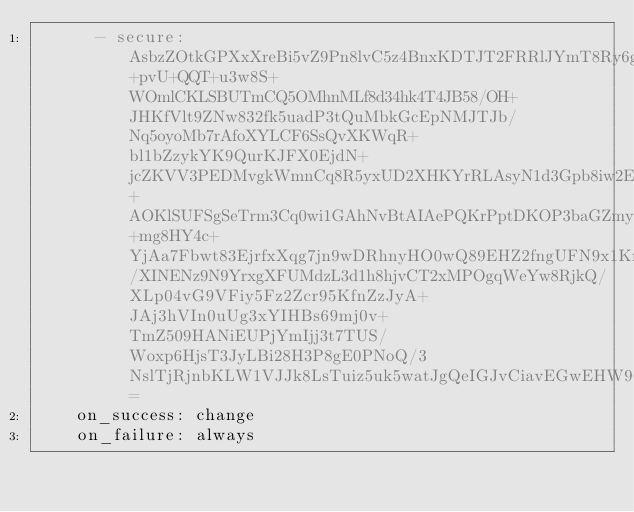Convert code to text. <code><loc_0><loc_0><loc_500><loc_500><_YAML_>      - secure: AsbzZOtkGPXxXreBi5vZ9Pn8lvC5z4BnxKDTJT2FRRlJYmT8Ry6gpLqrJWhdWTSDt7H+pvU+QQT+u3w8S+WOmlCKLSBUTmCQ5OMhnMLf8d34hk4T4JB58/OH+JHKfVlt9ZNw832fk5uadP3tQuMbkGcEpNMJTJb/Nq5oyoMb7rAfoXYLCF6SsQvXKWqR+bl1bZzykYK9QurKJFX0EjdN+jcZKVV3PEDMvgkWmnCq8R5yxUD2XHKYrRLAsyN1d3Gpb8iw2Edd2JSrLU4eTrbGXoBntZRvj3Y8hTmOAf95VIBypnaU1+AOKlSUFSgSeTrm3Cq0wi1GAhNvBtAIAePQKrPptDKOP3baGZmyIHZI1ma5SqY+mg8HY4c+YjAa7Fbwt83EjrfxXqg7jn9wDRhnyHO0wQ89EHZ2fngUFN9x1KrcYdjjuuLneEYzCZ2oSobfxJ3QExP24wGeD1Khx/XINENz9N9YrxgXFUMdzL3d1h8hjvCT2xMPOgqWeYw8RjkQ/XLp04vG9VFiy5Fz2Zcr95KfnZzJyA+JAj3hVIn0uUg3xYIHBs69mj0v+TmZ509HANiEUPjYmIjj3t7TUS/Woxp6HjsT3JyLBi28H3P8gE0PNoQ/3NslTjRjnbKLW1VJJk8LsTuiz5uk5watJgQeIGJvCiavEGwEHW96bCvibyo=
    on_success: change
    on_failure: always
</code> 